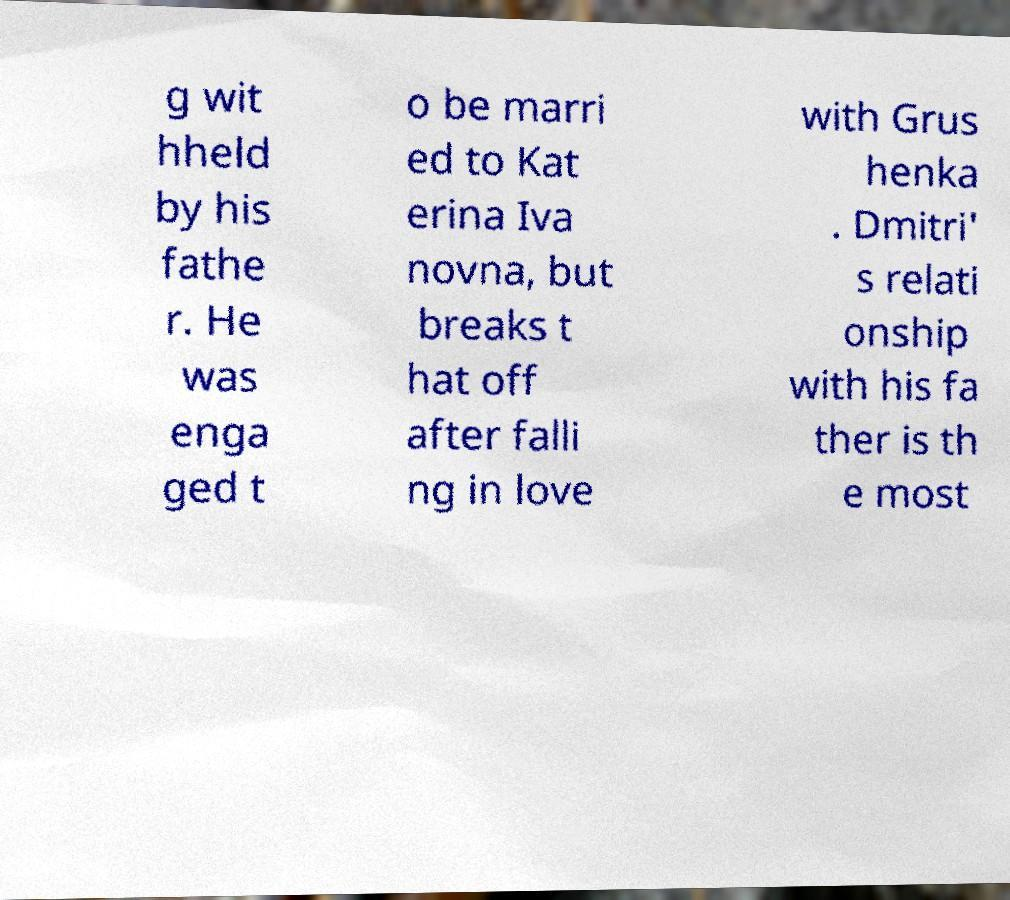Could you assist in decoding the text presented in this image and type it out clearly? g wit hheld by his fathe r. He was enga ged t o be marri ed to Kat erina Iva novna, but breaks t hat off after falli ng in love with Grus henka . Dmitri' s relati onship with his fa ther is th e most 